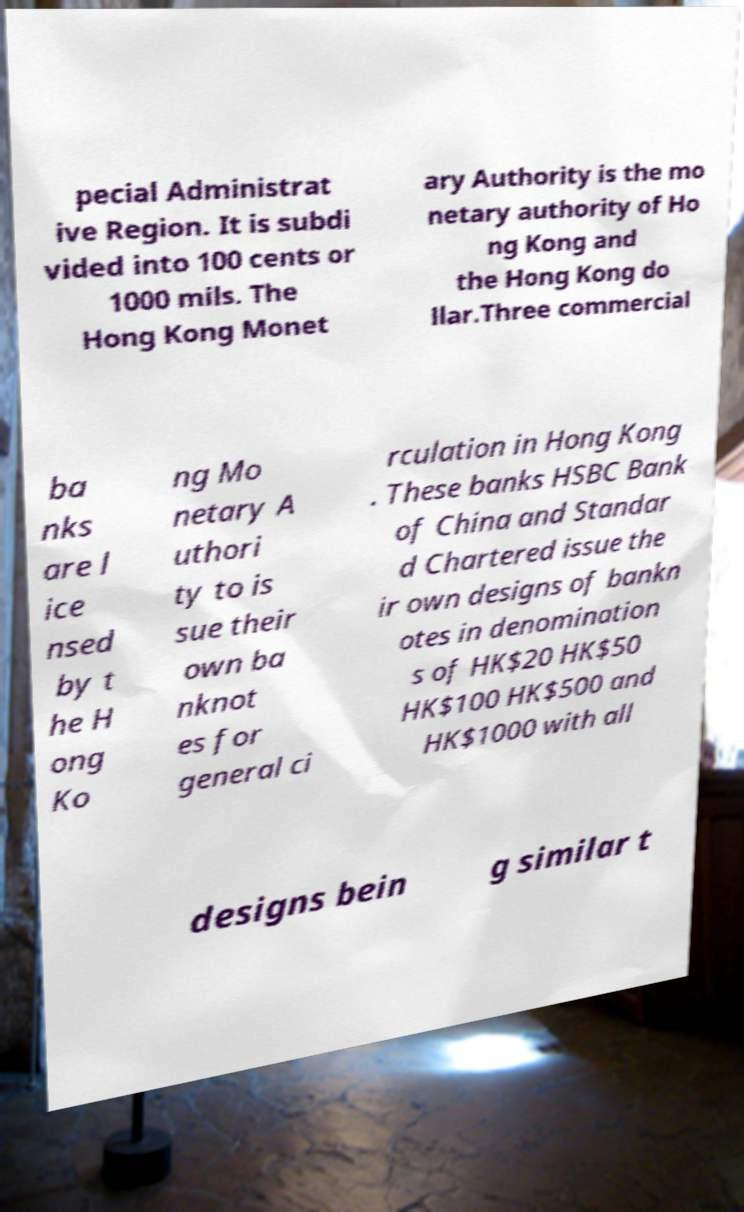Can you read and provide the text displayed in the image?This photo seems to have some interesting text. Can you extract and type it out for me? pecial Administrat ive Region. It is subdi vided into 100 cents or 1000 mils. The Hong Kong Monet ary Authority is the mo netary authority of Ho ng Kong and the Hong Kong do llar.Three commercial ba nks are l ice nsed by t he H ong Ko ng Mo netary A uthori ty to is sue their own ba nknot es for general ci rculation in Hong Kong . These banks HSBC Bank of China and Standar d Chartered issue the ir own designs of bankn otes in denomination s of HK$20 HK$50 HK$100 HK$500 and HK$1000 with all designs bein g similar t 